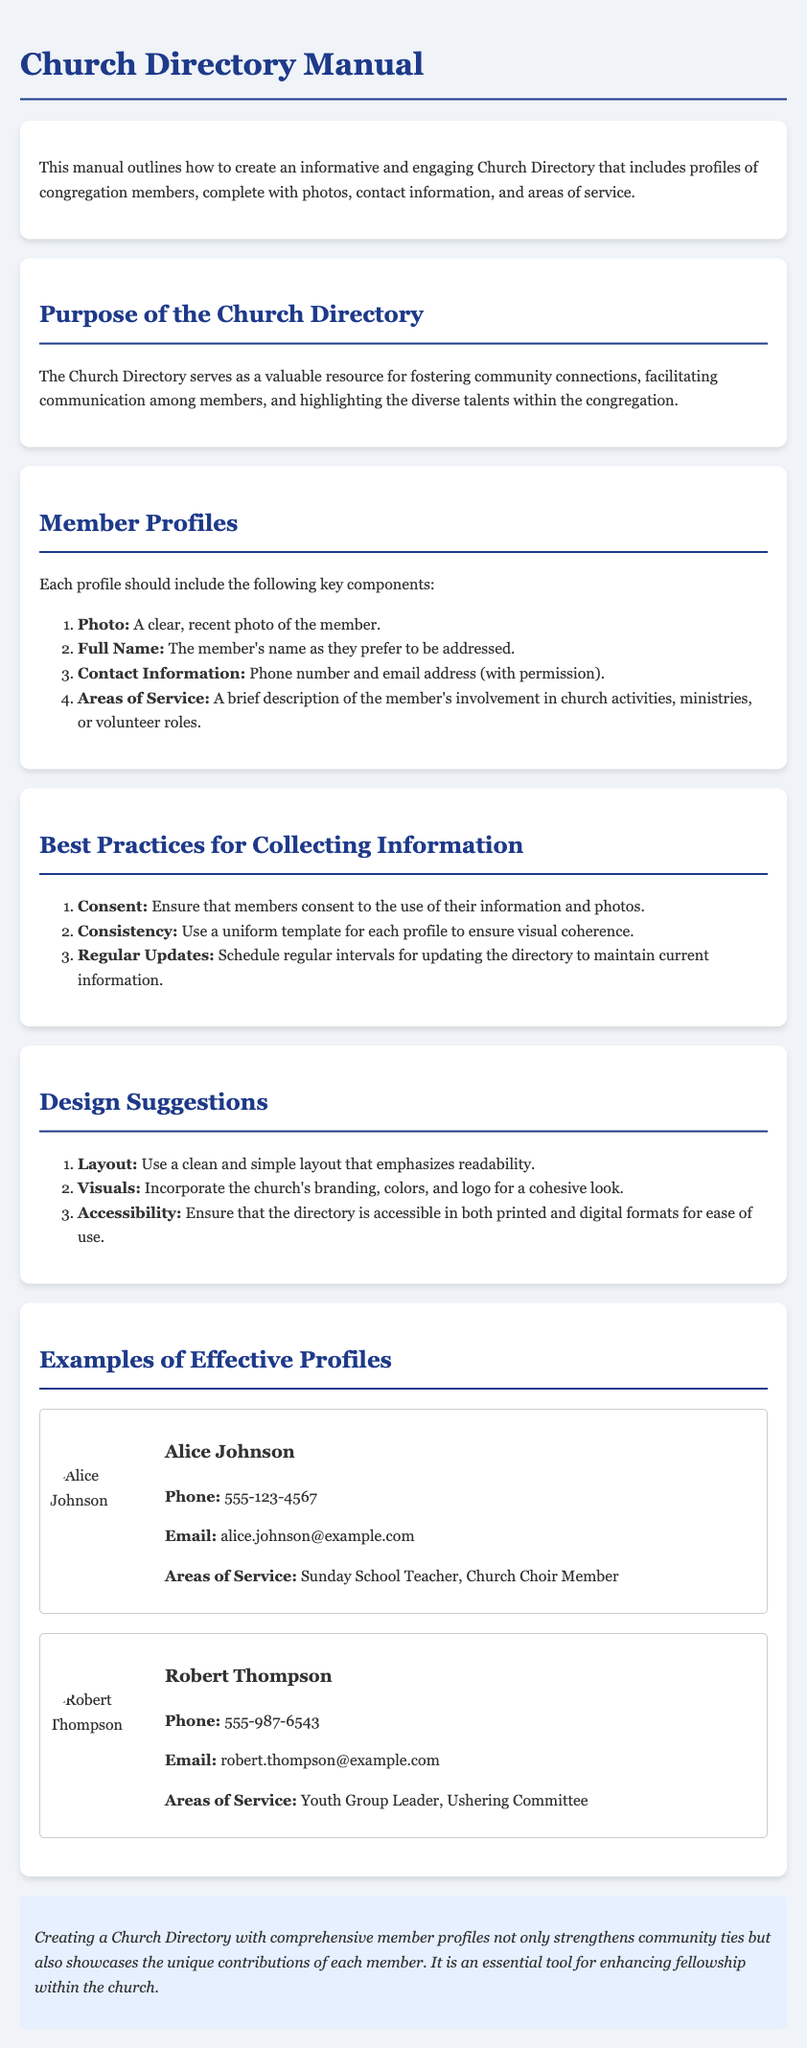What is the purpose of the Church Directory? The purpose of the Church Directory is described as serving as a valuable resource for fostering community connections, facilitating communication among members, and highlighting the diverse talents within the congregation.
Answer: Fostering community connections What type of information should each member profile include? The manual specifies that each profile should include a photo, full name, contact information, and areas of service, giving a clear outline of required components.
Answer: Photo, Full Name, Contact Information, Areas of Service What is the phone number of Alice Johnson? The phone number of Alice Johnson is provided in her profile section as a specific piece of information.
Answer: 555-123-4567 What area of service is Robert Thompson involved in? Robert Thompson's profile lists his areas of service, which are important to note for understanding his contributions to the church.
Answer: Youth Group Leader, Ushering Committee What design suggestion ensures coherence in member profiles? The document offers design suggestions focusing on aesthetics and functionality, highlighting the importance of uniformity in layout.
Answer: Use a uniform template How often should the directory be updated? The manual emphasizes the need for regular updates, indicating a time frame for maintaining current information.
Answer: Regular intervals What is a key best practice for collecting information? A crucial best practice mentioned in the document regarding the collection of information highlights the importance of validity and ethical communication.
Answer: Consent What color is recommended for the document theme? The manual provides guidance on visual design, including relevant colors that enhance the overall appearance of the directory.
Answer: #1e3a8a 